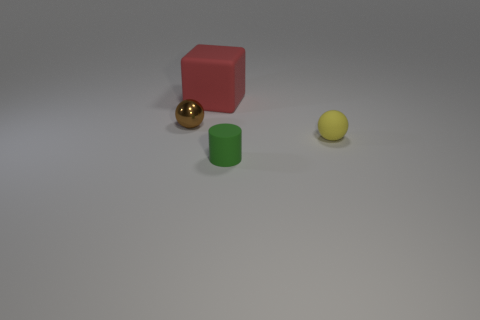Are there any other things that are the same size as the block?
Provide a short and direct response. No. How many other objects are there of the same size as the green matte cylinder?
Give a very brief answer. 2. Is the tiny thing that is in front of the tiny rubber ball made of the same material as the big red object?
Provide a succinct answer. Yes. How many other objects are the same color as the shiny sphere?
Ensure brevity in your answer.  0. How many other objects are the same shape as the big red thing?
Keep it short and to the point. 0. Is the shape of the small object on the left side of the big rubber thing the same as the thing behind the tiny metal ball?
Keep it short and to the point. No. Is the number of brown objects that are in front of the shiny object the same as the number of large matte things in front of the big matte object?
Make the answer very short. Yes. There is a matte thing behind the tiny ball that is on the right side of the tiny ball on the left side of the yellow ball; what shape is it?
Ensure brevity in your answer.  Cube. Are the small sphere that is behind the yellow sphere and the tiny ball that is in front of the small brown thing made of the same material?
Offer a very short reply. No. What is the shape of the matte thing left of the tiny green rubber object?
Offer a very short reply. Cube. 